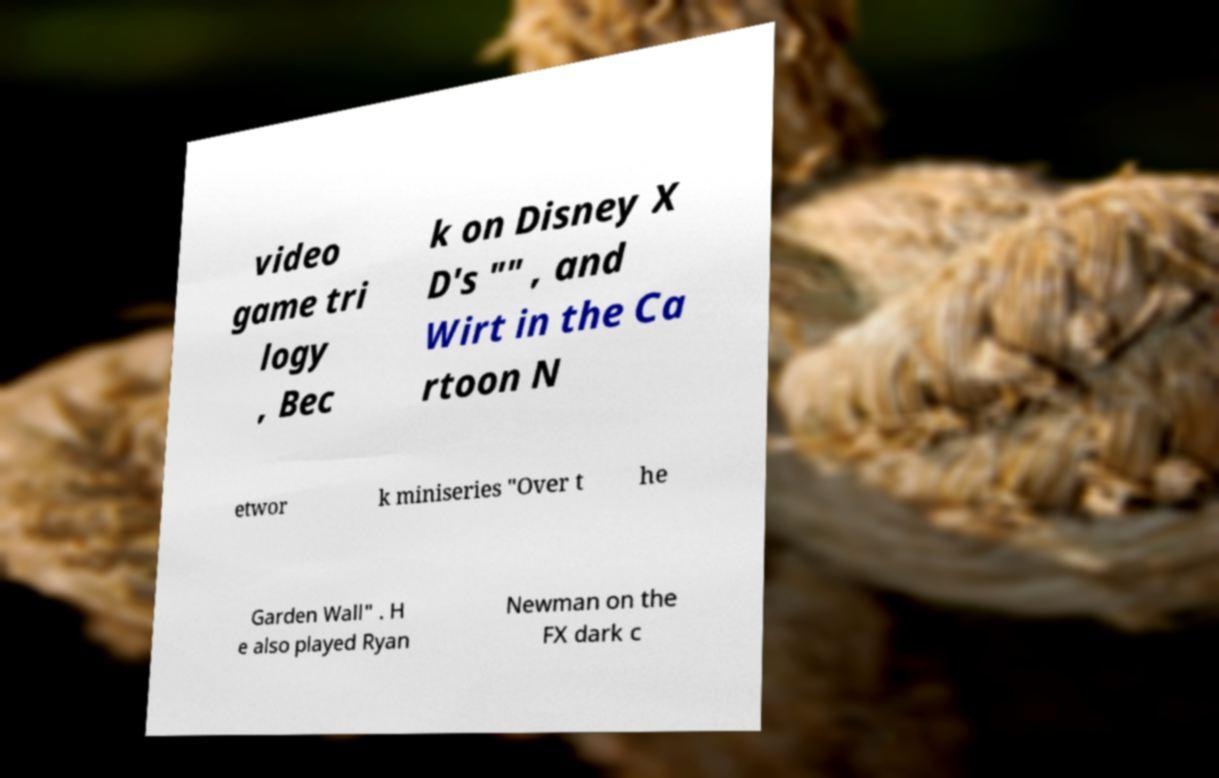Can you read and provide the text displayed in the image?This photo seems to have some interesting text. Can you extract and type it out for me? video game tri logy , Bec k on Disney X D's "" , and Wirt in the Ca rtoon N etwor k miniseries "Over t he Garden Wall" . H e also played Ryan Newman on the FX dark c 